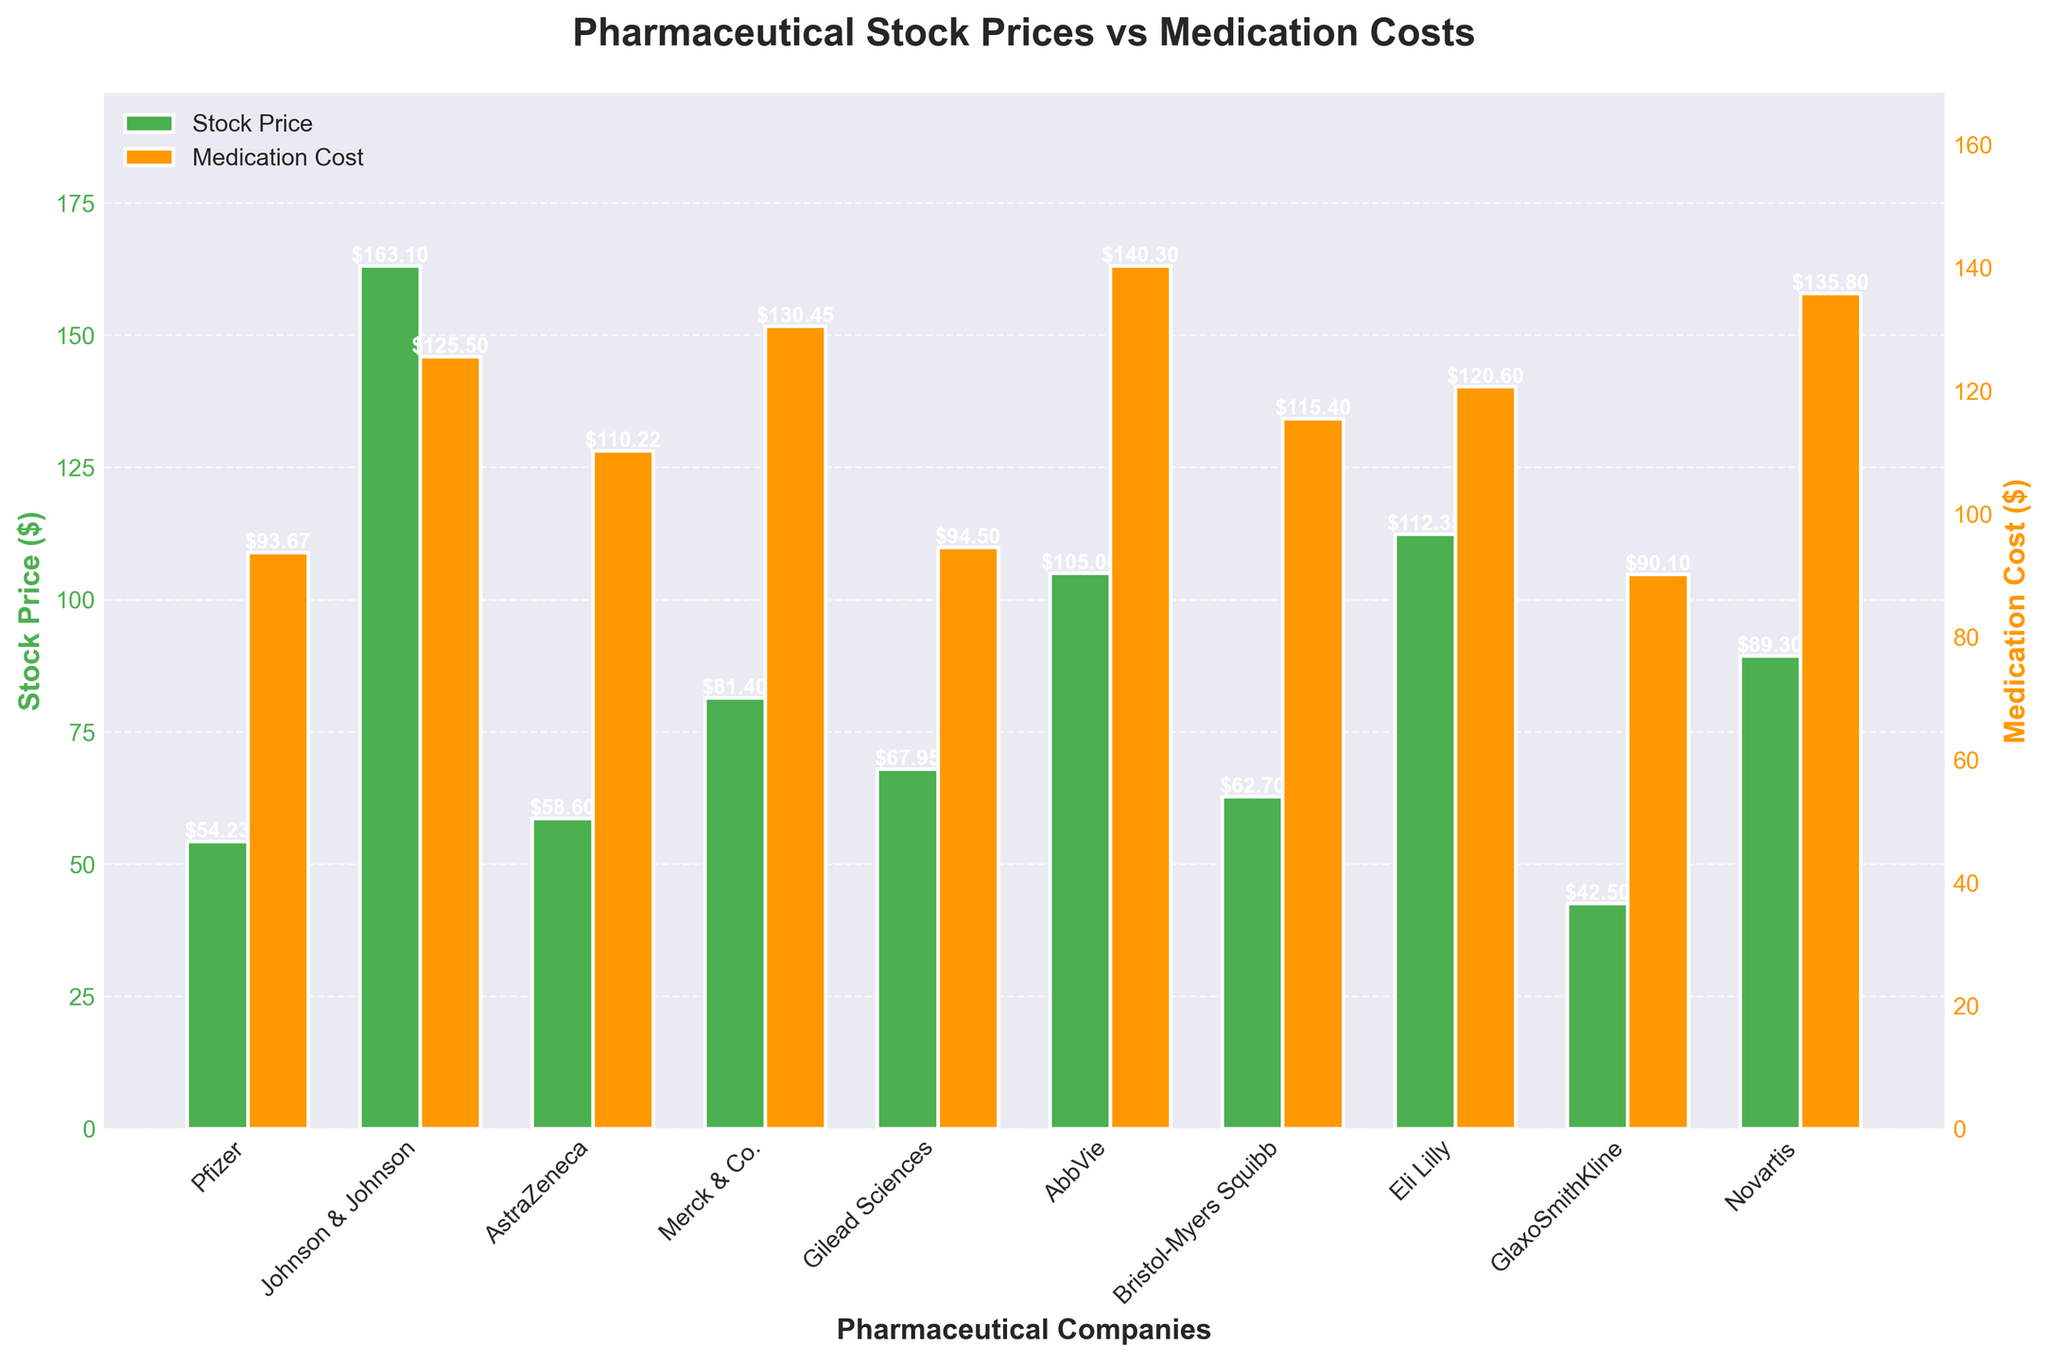What's the title of the figure? The title of a figure usually appears at the top and summarizes the content of the plot. In this figure, the title reads "Pharmaceutical Stock Prices vs Medication Costs".
Answer: Pharmaceutical Stock Prices vs Medication Costs How many pharmaceutical companies are represented in the figure? The number of pharmaceutical companies can be determined by counting the x-ticks on the x-axis, each labeled with a company's name. There are 10 x-ticks.
Answer: 10 Which pharmaceutical company has the highest stock price? To find the company with the highest stock price, look for the tallest green bar on the left y-axis. The tallest green bar belongs to Johnson & Johnson.
Answer: Johnson & Johnson Which medication has the highest cost? To find the medication with the highest cost, look at the heights of the orange bars on the right y-axis. The tallest orange bar corresponds to AbbVie's Humira.
Answer: Humira What is the stock price of Pfizer? Locate the green bar corresponding to Pfizer on the x-axis and read its height based on the left y-axis values. The height of Pfizer's bar is $54.23.
Answer: $54.23 What is the difference between the stock prices of Johnson & Johnson and Pfizer? Find both companies' stock prices from the green bars. Johnson & Johnson's price is $163.10, and Pfizer's is $54.23. Subtract Pfizer's price from Johnson & Johnson's to get the difference: $163.10 - $54.23.
Answer: $108.87 Which medication has a cost closer to $100? Compare all the orange bars' heights to the $100 mark on the right y-axis. Pfizer's Lipitor ($93.67), Gilead Sciences' Harvoni ($94.50), and GlaxoSmithKline's Advair ($90.10) are closest to $100, with Harvoni being the nearest.
Answer: Harvoni Which company has the lowest medication cost and what is it? To find the lowest medication cost, look at the shortest orange bar on the right y-axis. The shortest bar corresponds to GlaxoSmithKline's Advair with a cost of $90.10.
Answer: GlaxoSmithKline, $90.10 Is there a trend between stock prices and medication costs? Observing the bars' heights for both stock prices and medication costs shows that higher stock prices do not necessarily correlate with higher medication costs. For instance, Johnson & Johnson has the highest stock price but its medication cost isn't the highest.
Answer: No What is the average cost of medications listed? To calculate the average cost, sum all the medication costs and divide by the number of medications. The sum is $93.67 + $125.50 + $110.22 + $130.45 + $94.50 + $140.30 + $115.40 + $120.60 + $90.10 + $135.80 = $1146.54. Divide this by 10 to get the average: $1146.54 / 10.
Answer: $114.65 